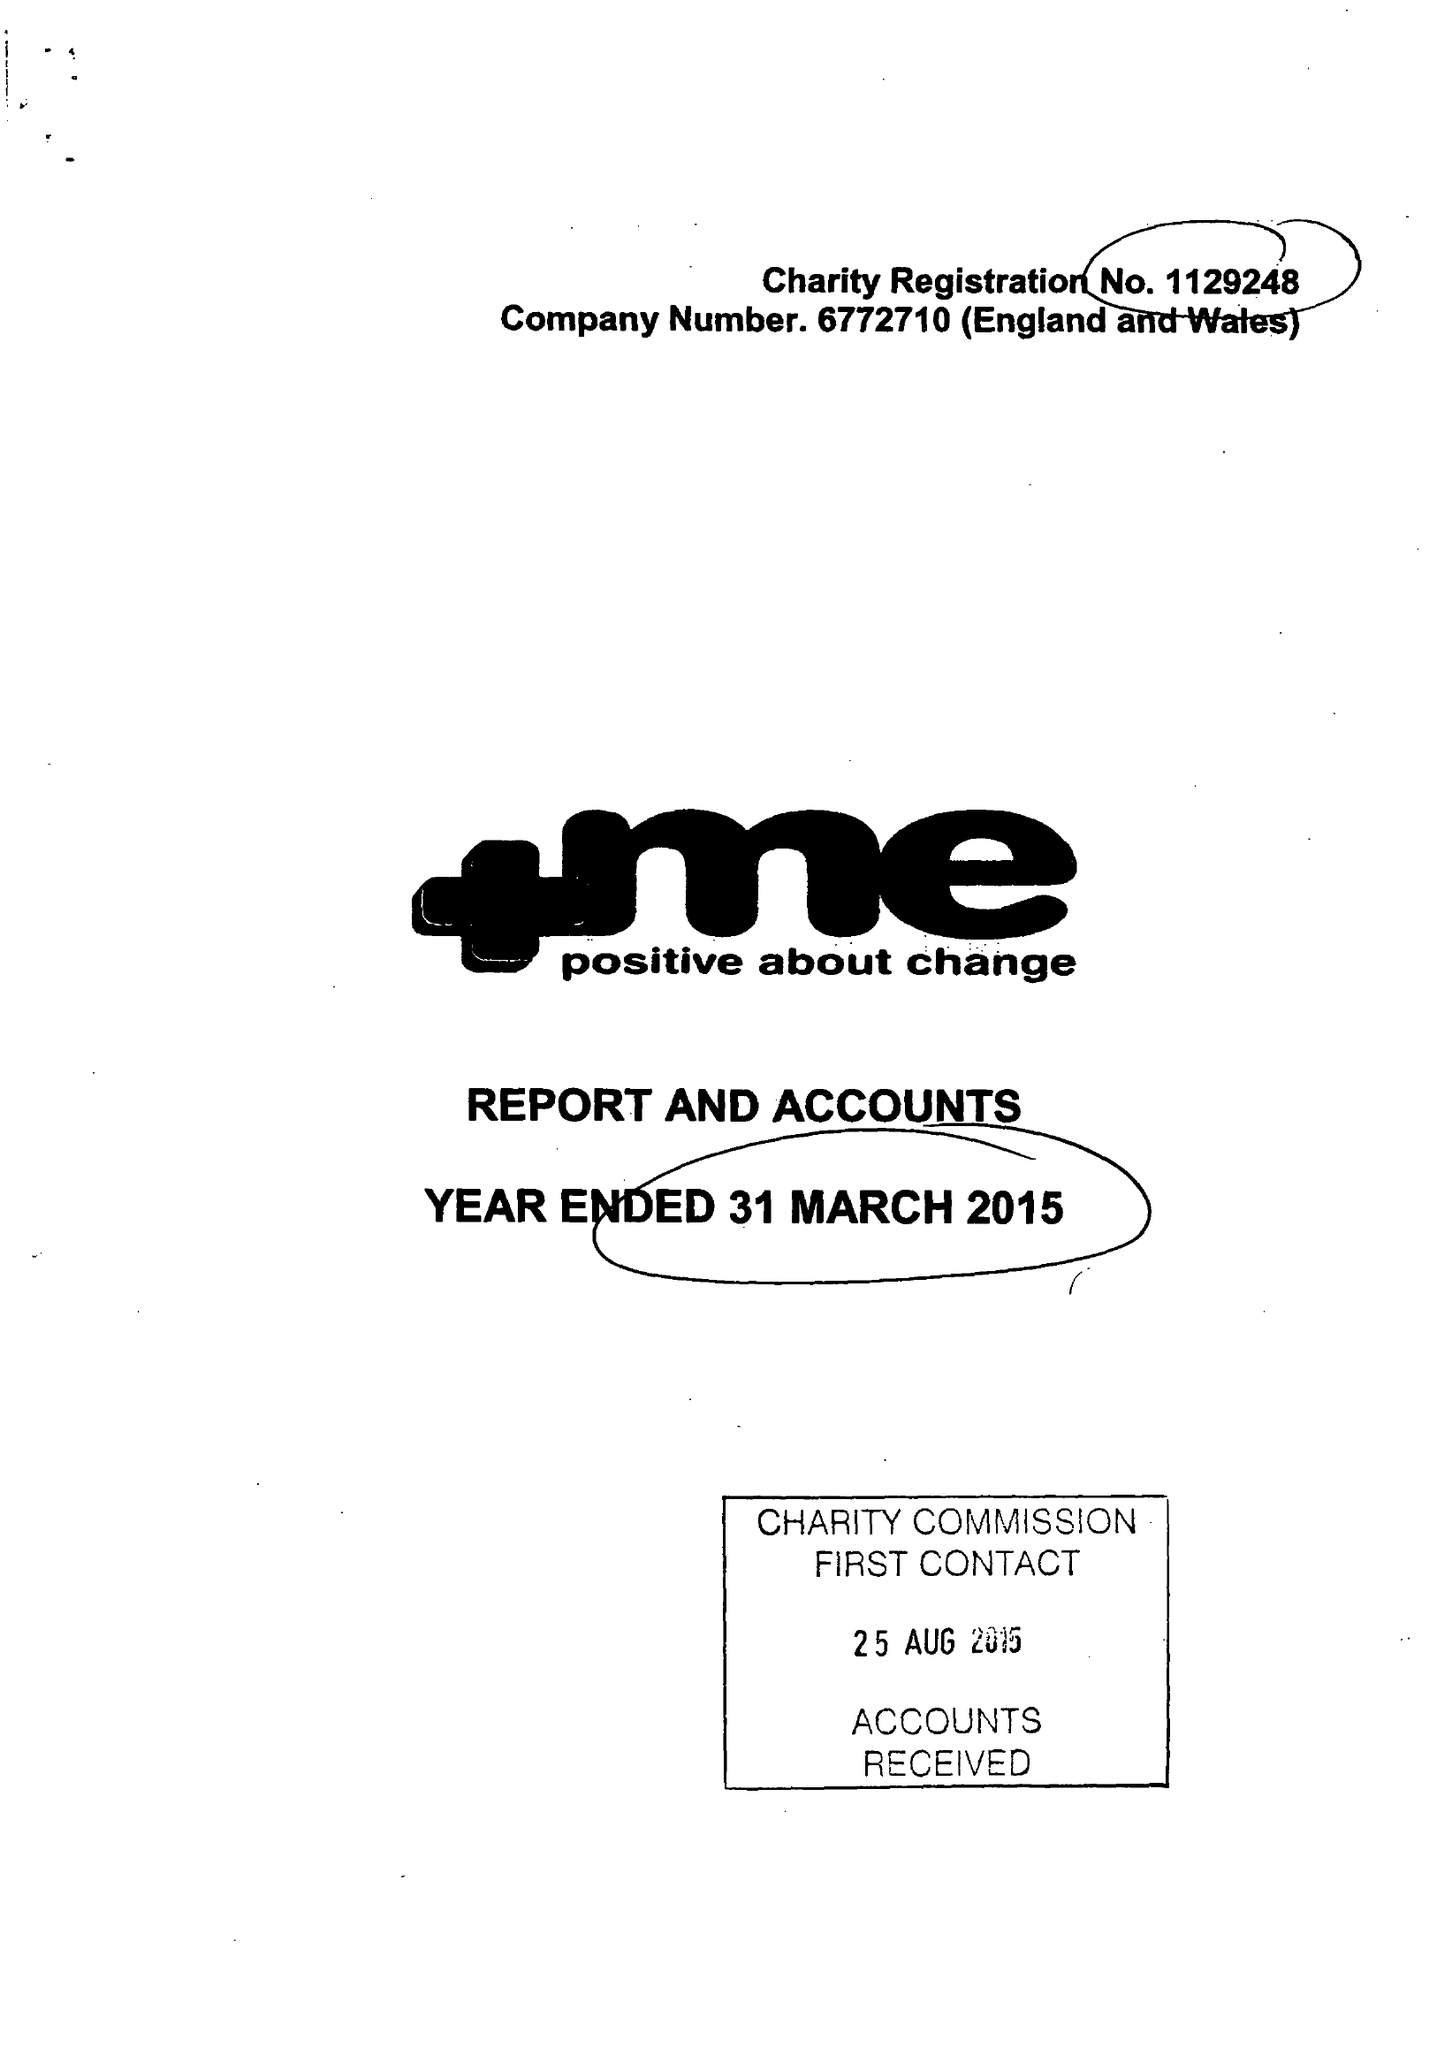What is the value for the address__post_town?
Answer the question using a single word or phrase. BARNSLEY 